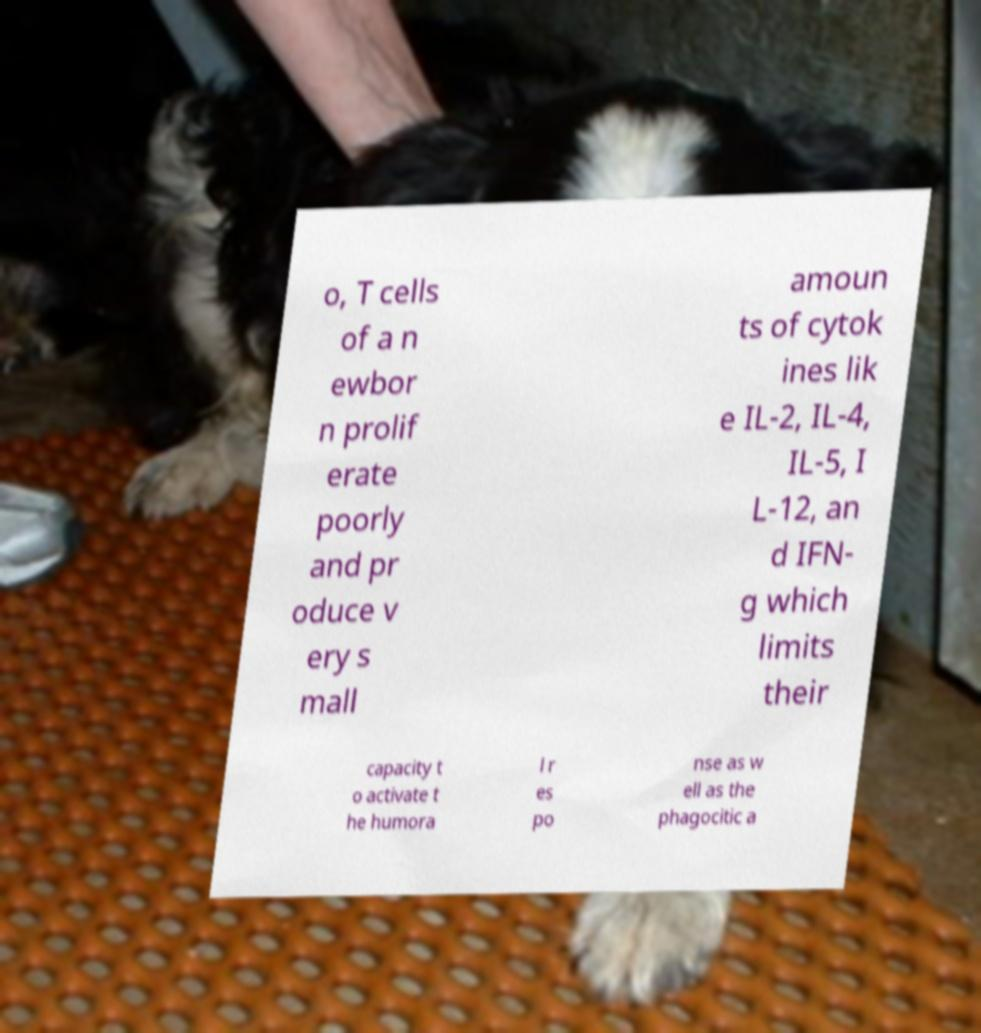Could you extract and type out the text from this image? o, T cells of a n ewbor n prolif erate poorly and pr oduce v ery s mall amoun ts of cytok ines lik e IL-2, IL-4, IL-5, I L-12, an d IFN- g which limits their capacity t o activate t he humora l r es po nse as w ell as the phagocitic a 